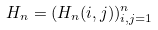<formula> <loc_0><loc_0><loc_500><loc_500>H _ { n } = ( H _ { n } ( i , j ) ) _ { i , j = 1 } ^ { n }</formula> 